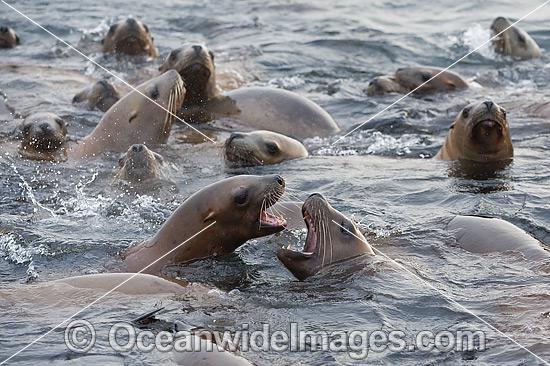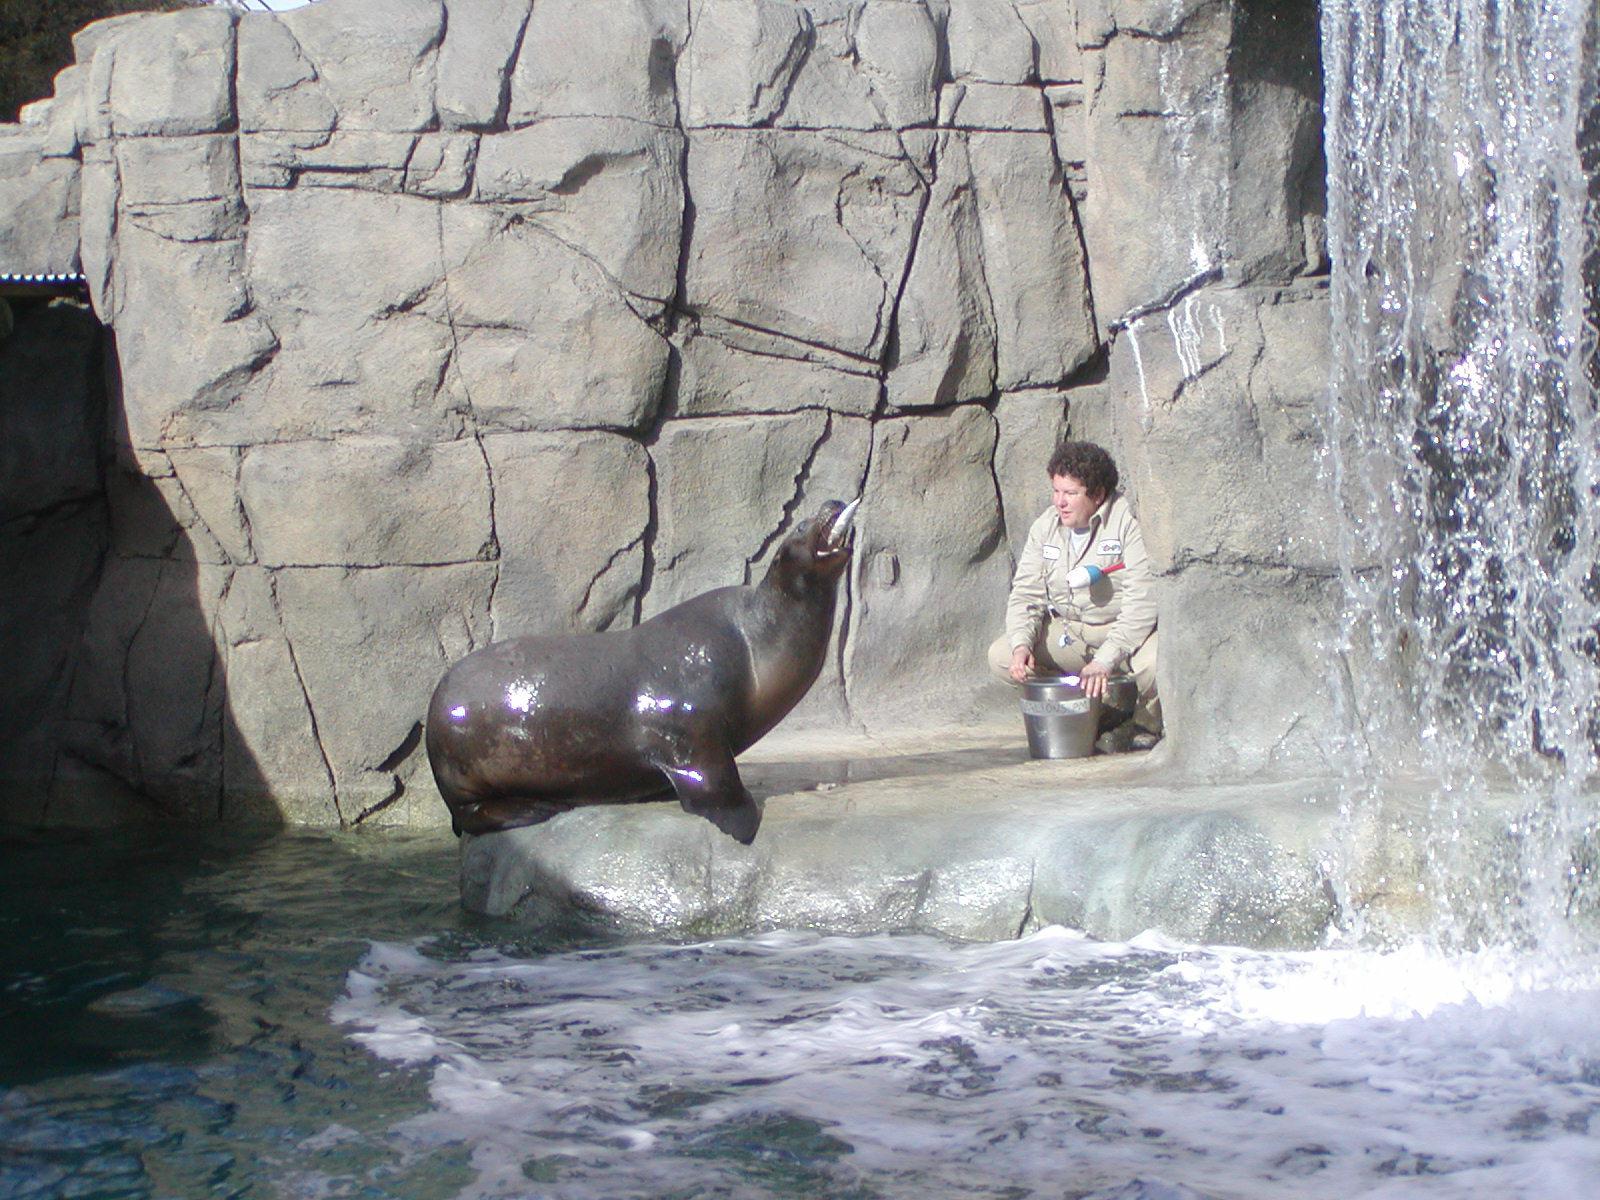The first image is the image on the left, the second image is the image on the right. Examine the images to the left and right. Is the description "seals are swimming in a square pool with a tone wall behind them" accurate? Answer yes or no. No. The first image is the image on the left, the second image is the image on the right. For the images shown, is this caption "In one image, there's an aquarist with at least one sea lion." true? Answer yes or no. Yes. 